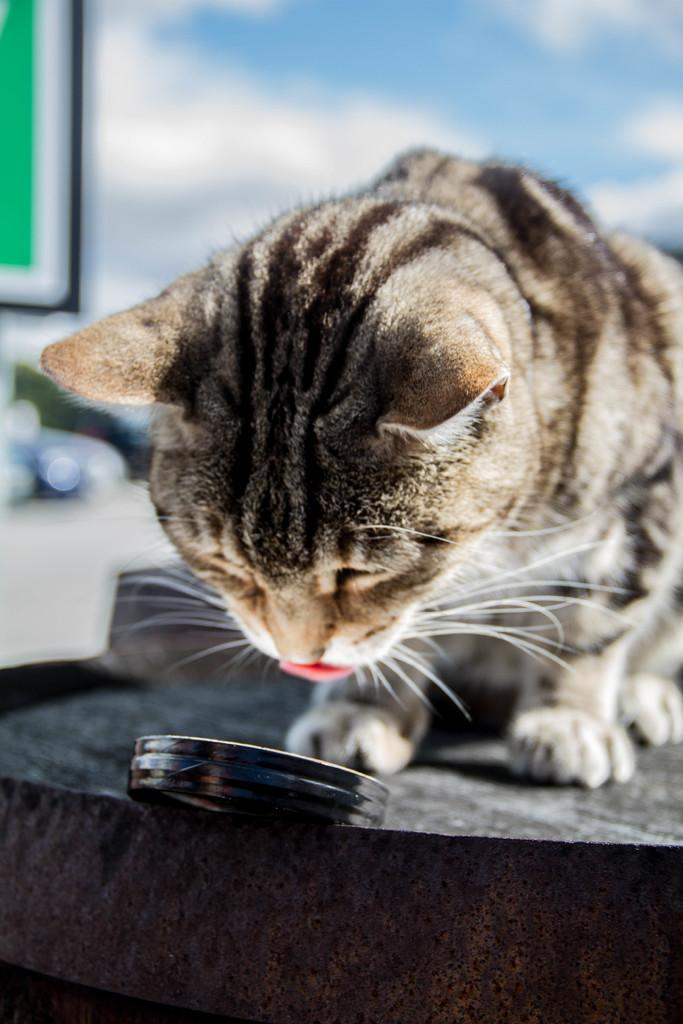What type of animal is in the image? There is a cat in the image. What color is the object at the bottom of the image? The object at the bottom of the image is black. Can you describe the background of the image? The background of the image is blurred. What type of cord is being used by the cat in the image? There is no cord present in the image; the cat is not using any cord. 